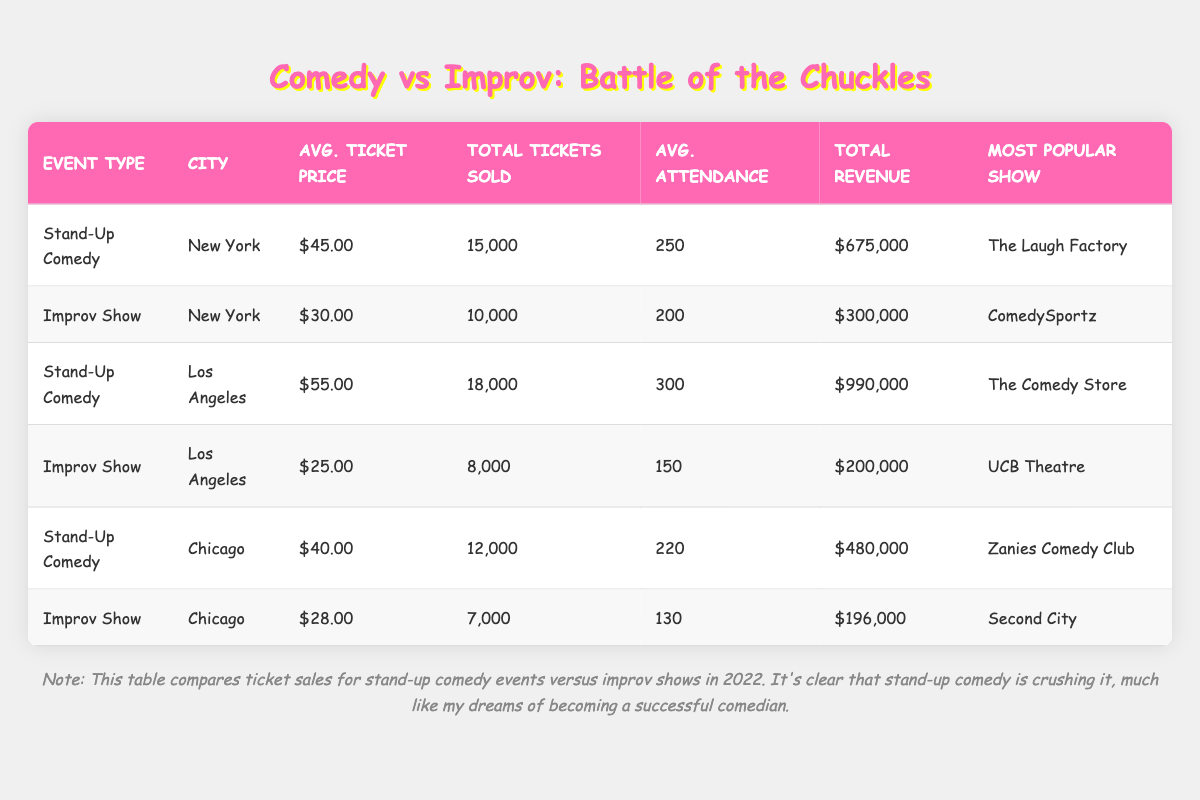What is the average ticket price for stand-up comedy events in Chicago? The average ticket price for stand-up comedy events in Chicago is provided directly in the table: it is $40.00.
Answer: $40.00 What event type sold more tickets in Los Angeles? In the table, we compare the total tickets sold for each event in Los Angeles: Stand-Up Comedy sold 18,000 tickets, while Improv Show sold 8,000 tickets. Clearly, Stand-Up Comedy sold more tickets.
Answer: Stand-Up Comedy What is the total revenue generated from improv shows in New York? The total revenue for improv shows in New York is listed in the table as $300,000, directly referencing the relevant row for that city and event type.
Answer: $300,000 How much more revenue did Stand-Up Comedy make than Improv Shows across all cities combined? To find this, we sum the total revenue for Stand-Up Comedy across New York, Los Angeles, and Chicago, yielding $675,000 + $990,000 + $480,000 = $2,145,000. For Improv Shows, we sum $300,000 + $200,000 + $196,000 = $696,000. The difference is $2,145,000 - $696,000 = $1,449,000.
Answer: $1,449,000 Is the most popular show for Improv in Chicago "ComedySportz"? In the table, the most popular show for Improv in Chicago is actually "Second City", not "ComedySportz". Therefore, this statement is false.
Answer: No Which city had the highest average attendance for comedy events? To determine this, we examine the average attendance for each event type in each city: New York: 250 (Stand-Up) and 200 (Improv), Los Angeles: 300 (Stand-Up) and 150 (Improv), Chicago: 220 (Stand-Up) and 130 (Improv). The highest average attendance is 300 in Los Angeles for Stand-Up Comedy.
Answer: Los Angeles What is the difference in average ticket prices between Stand-Up Comedy and Improv Shows in Chicago? We find the average ticket prices for both events in Chicago: Stand-Up Comedy is $40.00 and Improv Show is $28.00. The difference is $40.00 - $28.00 = $12.00.
Answer: $12.00 Which event had the lowest average attendance overall? The average attendance for Improv Shows in Los Angeles is 150, which is less than any other recorded average attendances for either event type in all cities presented.
Answer: Improv Show in Los Angeles 